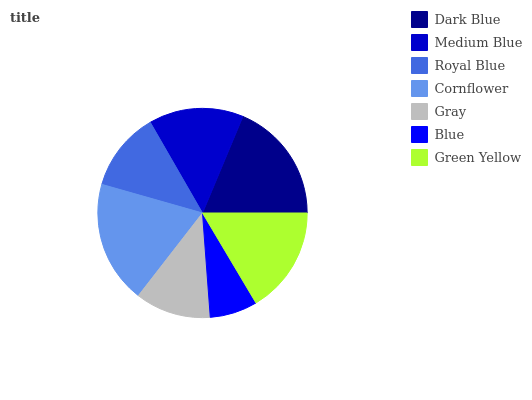Is Blue the minimum?
Answer yes or no. Yes. Is Cornflower the maximum?
Answer yes or no. Yes. Is Medium Blue the minimum?
Answer yes or no. No. Is Medium Blue the maximum?
Answer yes or no. No. Is Dark Blue greater than Medium Blue?
Answer yes or no. Yes. Is Medium Blue less than Dark Blue?
Answer yes or no. Yes. Is Medium Blue greater than Dark Blue?
Answer yes or no. No. Is Dark Blue less than Medium Blue?
Answer yes or no. No. Is Medium Blue the high median?
Answer yes or no. Yes. Is Medium Blue the low median?
Answer yes or no. Yes. Is Gray the high median?
Answer yes or no. No. Is Royal Blue the low median?
Answer yes or no. No. 